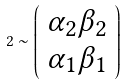Convert formula to latex. <formula><loc_0><loc_0><loc_500><loc_500>2 \sim \left ( \begin{array} { c } \alpha _ { 2 } \beta _ { 2 } \\ \alpha _ { 1 } \beta _ { 1 } \end{array} \right )</formula> 